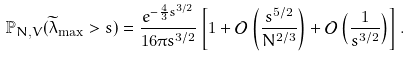<formula> <loc_0><loc_0><loc_500><loc_500>\mathbb { P } _ { N , V } ( \widetilde { \lambda } _ { \max } > s ) = \frac { e ^ { - \frac { 4 } { 3 } s ^ { 3 / 2 } } } { 1 6 \pi s ^ { 3 / 2 } } \left [ 1 + \mathcal { O } \left ( \frac { s ^ { 5 / 2 } } { N ^ { 2 / 3 } } \right ) + \mathcal { O } \left ( \frac { 1 } { s ^ { 3 / 2 } } \right ) \right ] .</formula> 